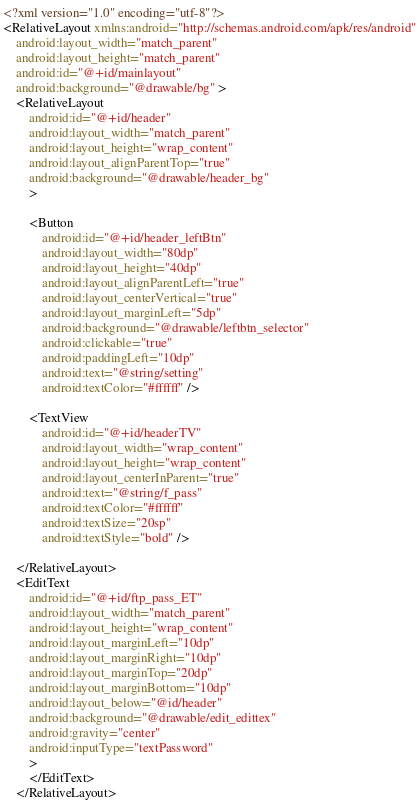Convert code to text. <code><loc_0><loc_0><loc_500><loc_500><_XML_><?xml version="1.0" encoding="utf-8"?>
<RelativeLayout xmlns:android="http://schemas.android.com/apk/res/android"
    android:layout_width="match_parent"
    android:layout_height="match_parent"
    android:id="@+id/mainlayout" 
    android:background="@drawable/bg" >
    <RelativeLayout
        android:id="@+id/header"
        android:layout_width="match_parent"
        android:layout_height="wrap_content"
        android:layout_alignParentTop="true"
        android:background="@drawable/header_bg"
        >

        <Button
            android:id="@+id/header_leftBtn"
            android:layout_width="80dp"
            android:layout_height="40dp"
            android:layout_alignParentLeft="true"
            android:layout_centerVertical="true"
            android:layout_marginLeft="5dp"
            android:background="@drawable/leftbtn_selector"
            android:clickable="true"
            android:paddingLeft="10dp"
            android:text="@string/setting"
            android:textColor="#ffffff" />

        <TextView
            android:id="@+id/headerTV"
            android:layout_width="wrap_content"
            android:layout_height="wrap_content"
            android:layout_centerInParent="true"
            android:text="@string/f_pass"
            android:textColor="#ffffff"
            android:textSize="20sp"
            android:textStyle="bold" />

    </RelativeLayout>
    <EditText
        android:id="@+id/ftp_pass_ET"
        android:layout_width="match_parent"
        android:layout_height="wrap_content"
        android:layout_marginLeft="10dp"
        android:layout_marginRight="10dp"
        android:layout_marginTop="20dp"
        android:layout_marginBottom="10dp"
        android:layout_below="@id/header"
        android:background="@drawable/edit_edittex"
        android:gravity="center"
        android:inputType="textPassword"
        >
        </EditText>
    </RelativeLayout></code> 